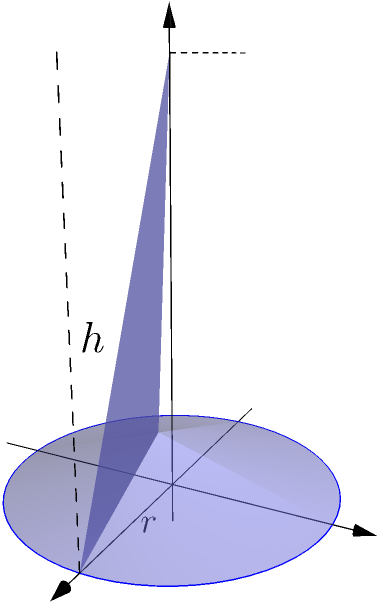As part of your college physics project, you're designing a cylindrical water tank for a community garden. The tank has a radius of 2 meters and a height of 5 meters. What is the volume of water this tank can hold in cubic meters? Let's approach this step-by-step:

1) The formula for the volume of a cylinder is:
   $$V = \pi r^2 h$$
   where $V$ is volume, $r$ is radius, and $h$ is height.

2) We're given:
   Radius ($r$) = 2 meters
   Height ($h$) = 5 meters

3) Let's substitute these values into our formula:
   $$V = \pi (2 \text{ m})^2 (5 \text{ m})$$

4) First, calculate the squared radius:
   $$V = \pi (4 \text{ m}^2) (5 \text{ m})$$

5) Multiply the values inside the parentheses:
   $$V = \pi (20 \text{ m}^3)$$

6) Now, multiply by $\pi$. We'll use 3.14159 as an approximation for $\pi$:
   $$V = 3.14159 (20 \text{ m}^3) = 62.8318 \text{ m}^3$$

7) Rounding to two decimal places:
   $$V \approx 62.83 \text{ m}^3$$
Answer: 62.83 m³ 